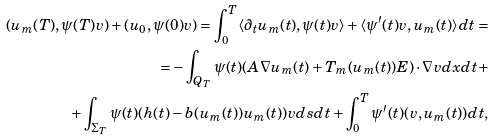<formula> <loc_0><loc_0><loc_500><loc_500>( u _ { m } ( T ) , \psi ( T ) v ) + ( u _ { 0 } , \psi ( 0 ) v ) = \int _ { 0 } ^ { T } \langle \partial _ { t } u _ { m } ( t ) , \psi ( t ) v \rangle + \langle \psi ^ { \prime } ( t ) v , u _ { m } ( t ) \rangle d t = \\ = - \int _ { Q _ { T } } \psi ( t ) ( A \nabla u _ { m } ( t ) + T _ { m } ( u _ { m } ( t ) ) { E } ) \cdot \nabla v d x d t + \\ + \int _ { \Sigma _ { T } } \psi ( t ) ( h ( t ) - b ( u _ { m } ( t ) ) u _ { m } ( t ) ) v d s d t + \int _ { 0 } ^ { T } \psi ^ { \prime } ( t ) ( v , u _ { m } ( t ) ) d t ,</formula> 